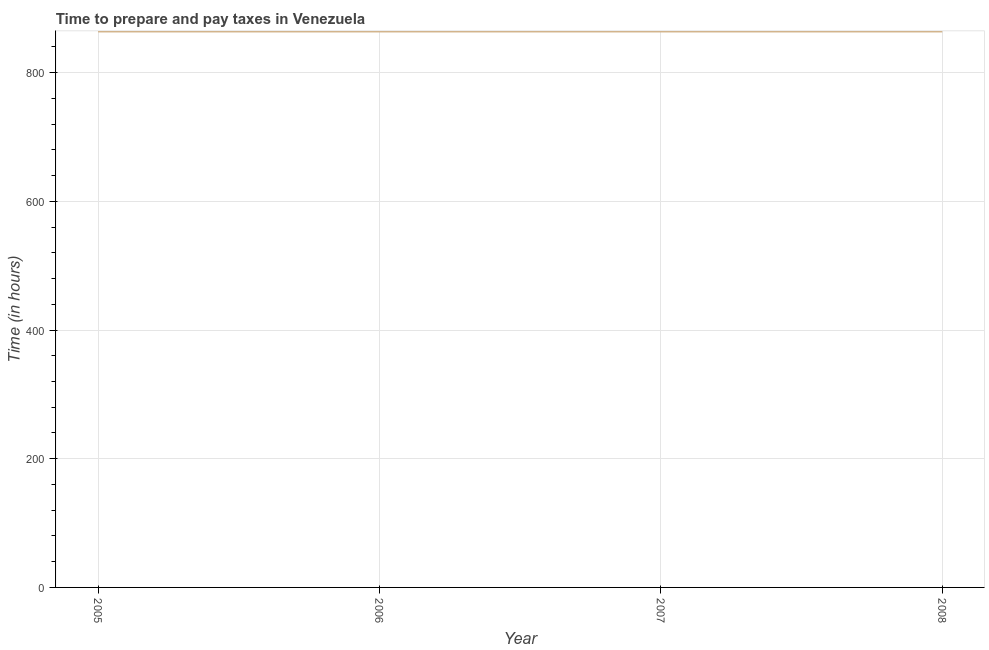What is the time to prepare and pay taxes in 2005?
Your answer should be compact. 864. Across all years, what is the maximum time to prepare and pay taxes?
Your answer should be very brief. 864. Across all years, what is the minimum time to prepare and pay taxes?
Your response must be concise. 864. In which year was the time to prepare and pay taxes maximum?
Provide a short and direct response. 2005. In which year was the time to prepare and pay taxes minimum?
Ensure brevity in your answer.  2005. What is the sum of the time to prepare and pay taxes?
Provide a short and direct response. 3456. What is the average time to prepare and pay taxes per year?
Provide a short and direct response. 864. What is the median time to prepare and pay taxes?
Give a very brief answer. 864. In how many years, is the time to prepare and pay taxes greater than 560 hours?
Offer a terse response. 4. What is the ratio of the time to prepare and pay taxes in 2006 to that in 2008?
Offer a very short reply. 1. Is the time to prepare and pay taxes in 2007 less than that in 2008?
Provide a short and direct response. No. Is the difference between the time to prepare and pay taxes in 2005 and 2006 greater than the difference between any two years?
Ensure brevity in your answer.  Yes. Is the sum of the time to prepare and pay taxes in 2005 and 2006 greater than the maximum time to prepare and pay taxes across all years?
Your response must be concise. Yes. What is the difference between the highest and the lowest time to prepare and pay taxes?
Your answer should be compact. 0. How many lines are there?
Offer a terse response. 1. Are the values on the major ticks of Y-axis written in scientific E-notation?
Offer a very short reply. No. Does the graph contain grids?
Give a very brief answer. Yes. What is the title of the graph?
Make the answer very short. Time to prepare and pay taxes in Venezuela. What is the label or title of the X-axis?
Offer a terse response. Year. What is the label or title of the Y-axis?
Your answer should be very brief. Time (in hours). What is the Time (in hours) in 2005?
Ensure brevity in your answer.  864. What is the Time (in hours) of 2006?
Offer a terse response. 864. What is the Time (in hours) of 2007?
Provide a short and direct response. 864. What is the Time (in hours) in 2008?
Provide a succinct answer. 864. What is the difference between the Time (in hours) in 2005 and 2007?
Keep it short and to the point. 0. What is the difference between the Time (in hours) in 2005 and 2008?
Offer a terse response. 0. What is the ratio of the Time (in hours) in 2005 to that in 2007?
Offer a terse response. 1. What is the ratio of the Time (in hours) in 2006 to that in 2008?
Ensure brevity in your answer.  1. 